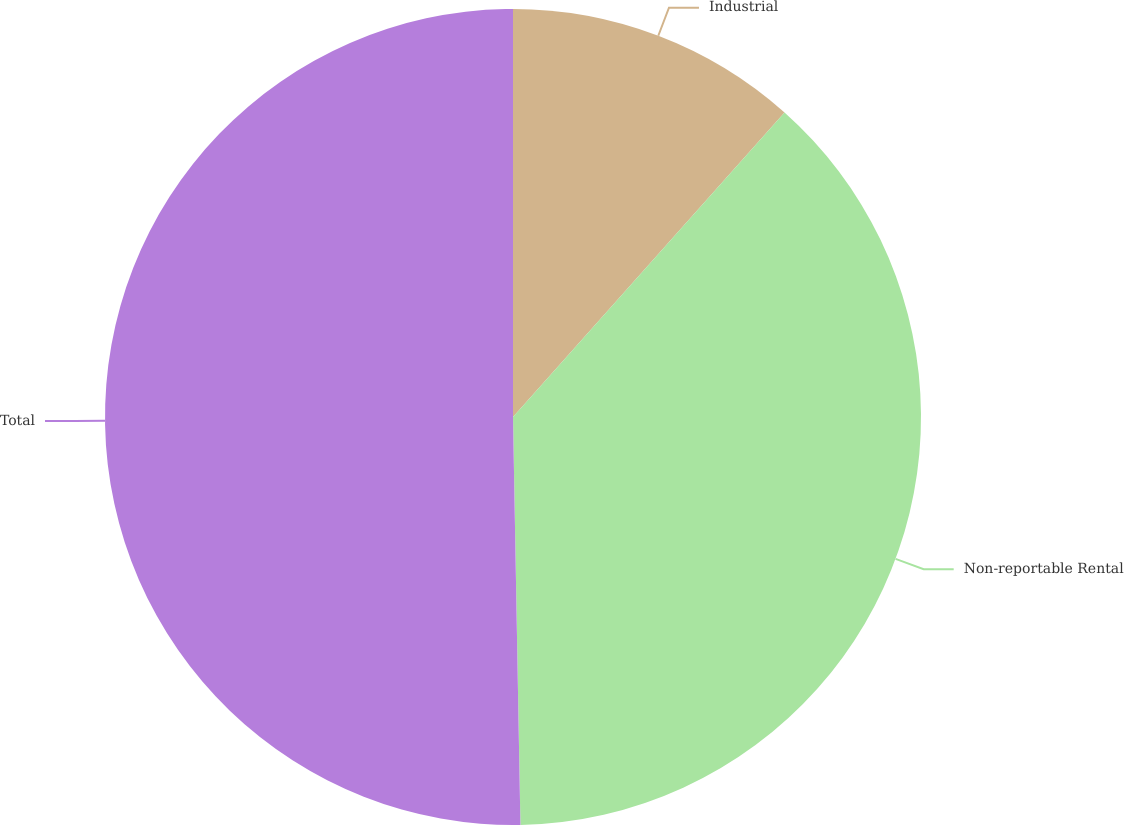Convert chart. <chart><loc_0><loc_0><loc_500><loc_500><pie_chart><fcel>Industrial<fcel>Non-reportable Rental<fcel>Total<nl><fcel>11.59%<fcel>38.12%<fcel>50.29%<nl></chart> 